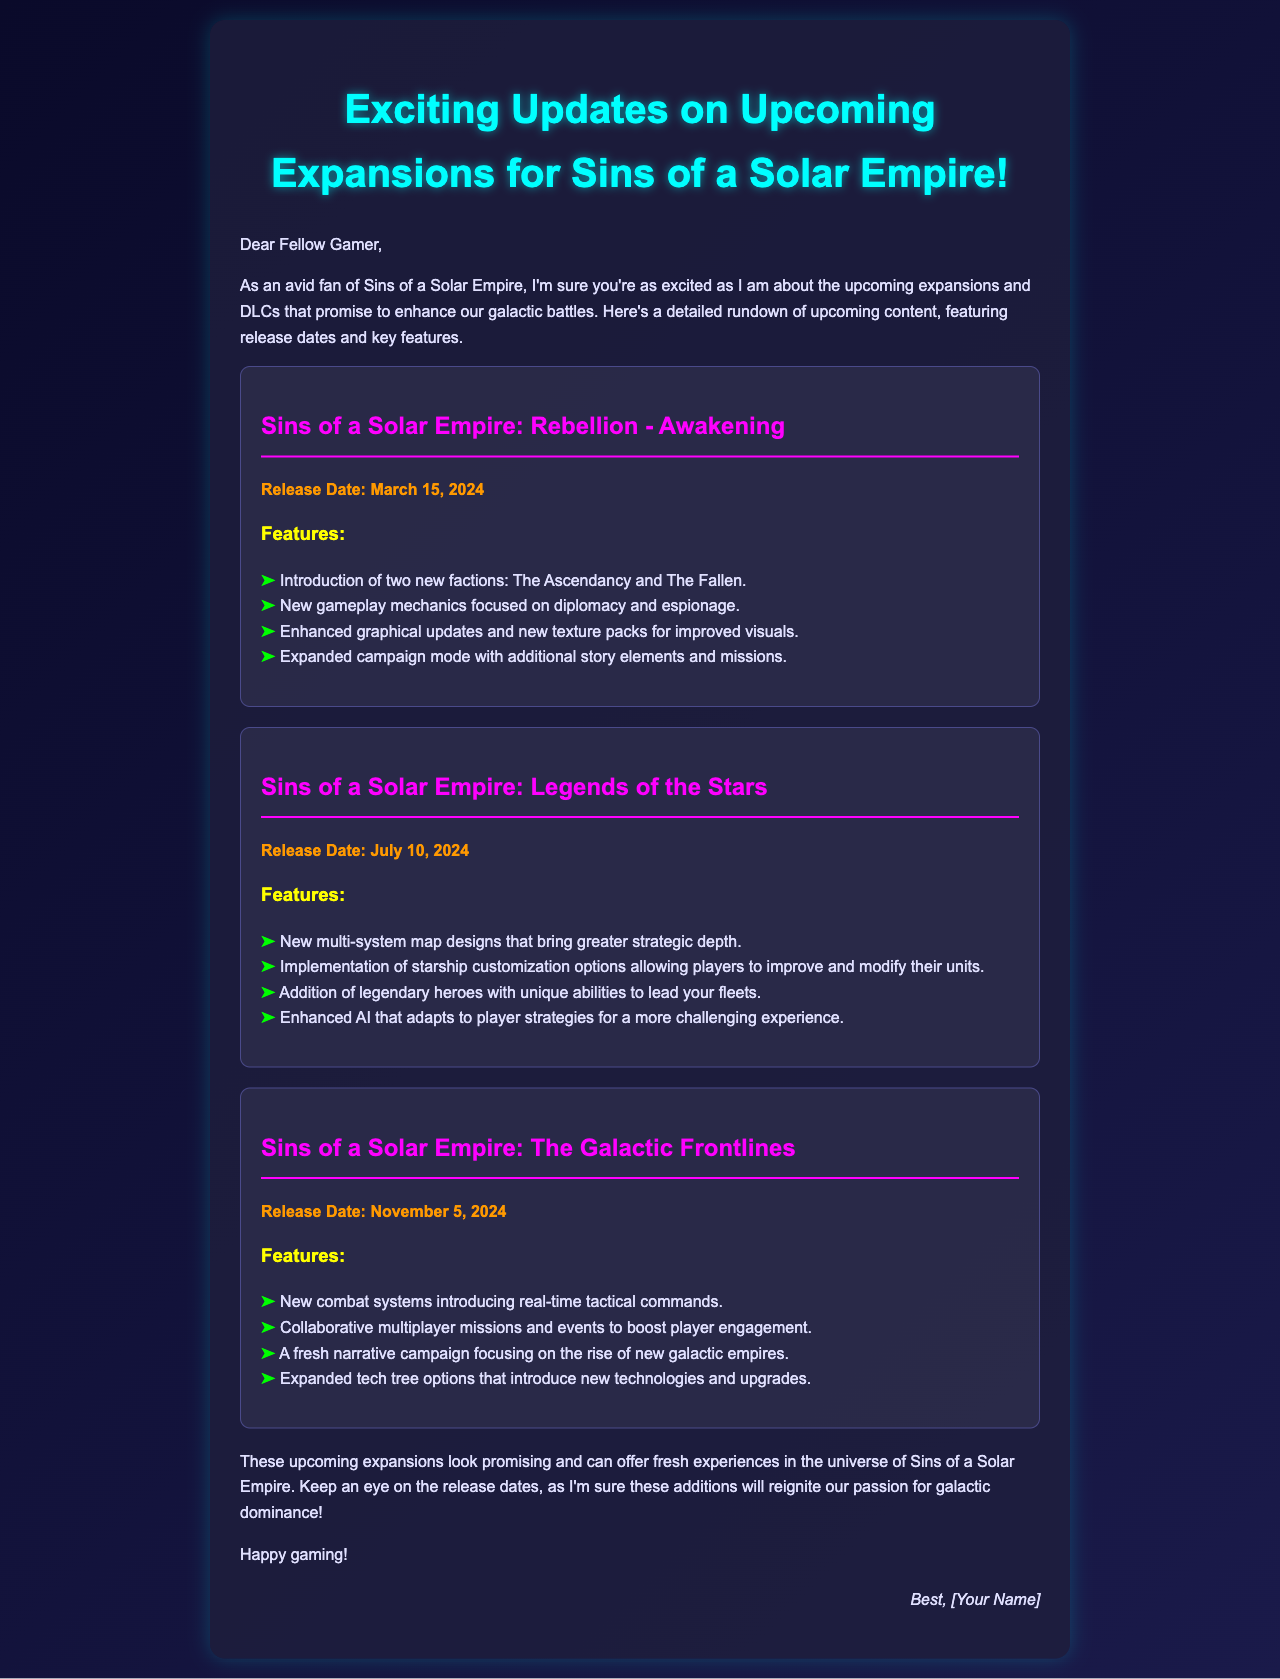What is the release date for Sins of a Solar Empire: Rebellion - Awakening? The document specifically states the release date for this expansion as March 15, 2024.
Answer: March 15, 2024 What are the new factions introduced in Sins of a Solar Empire: Rebellion - Awakening? The email lists two new factions: The Ascendancy and The Fallen.
Answer: The Ascendancy and The Fallen When will Sins of a Solar Empire: Legends of the Stars be released? The document indicates that the release date for this expansion is July 10, 2024.
Answer: July 10, 2024 What gameplay feature is added in Sins of a Solar Empire: Legends of the Stars? It specifically mentions the implementation of starship customization options as a feature in this expansion.
Answer: Starship customization options How many expansions are mentioned in the document? The email outlines three distinct expansions for Sins of a Solar Empire.
Answer: Three What is the final release date mentioned in the email? The last expansion listed in the document has a release date of November 5, 2024.
Answer: November 5, 2024 What is a new combat system introduced in Sins of a Solar Empire: The Galactic Frontlines? The document specifies that a new combat system will introduce real-time tactical commands.
Answer: Real-time tactical commands Which expansion includes new gameplay mechanics focused on diplomacy? The document clarifies that Sins of a Solar Empire: Rebellion - Awakening introduces gameplay mechanics focused on diplomacy.
Answer: Sins of a Solar Empire: Rebellion - Awakening 